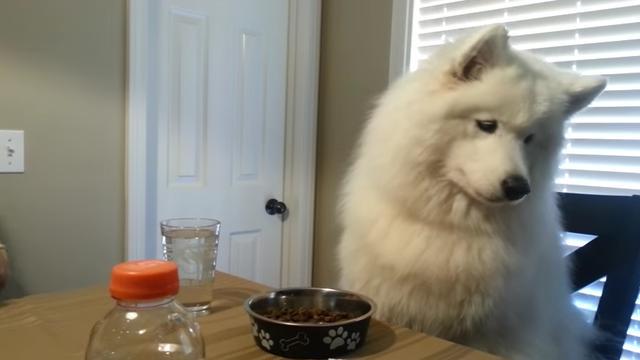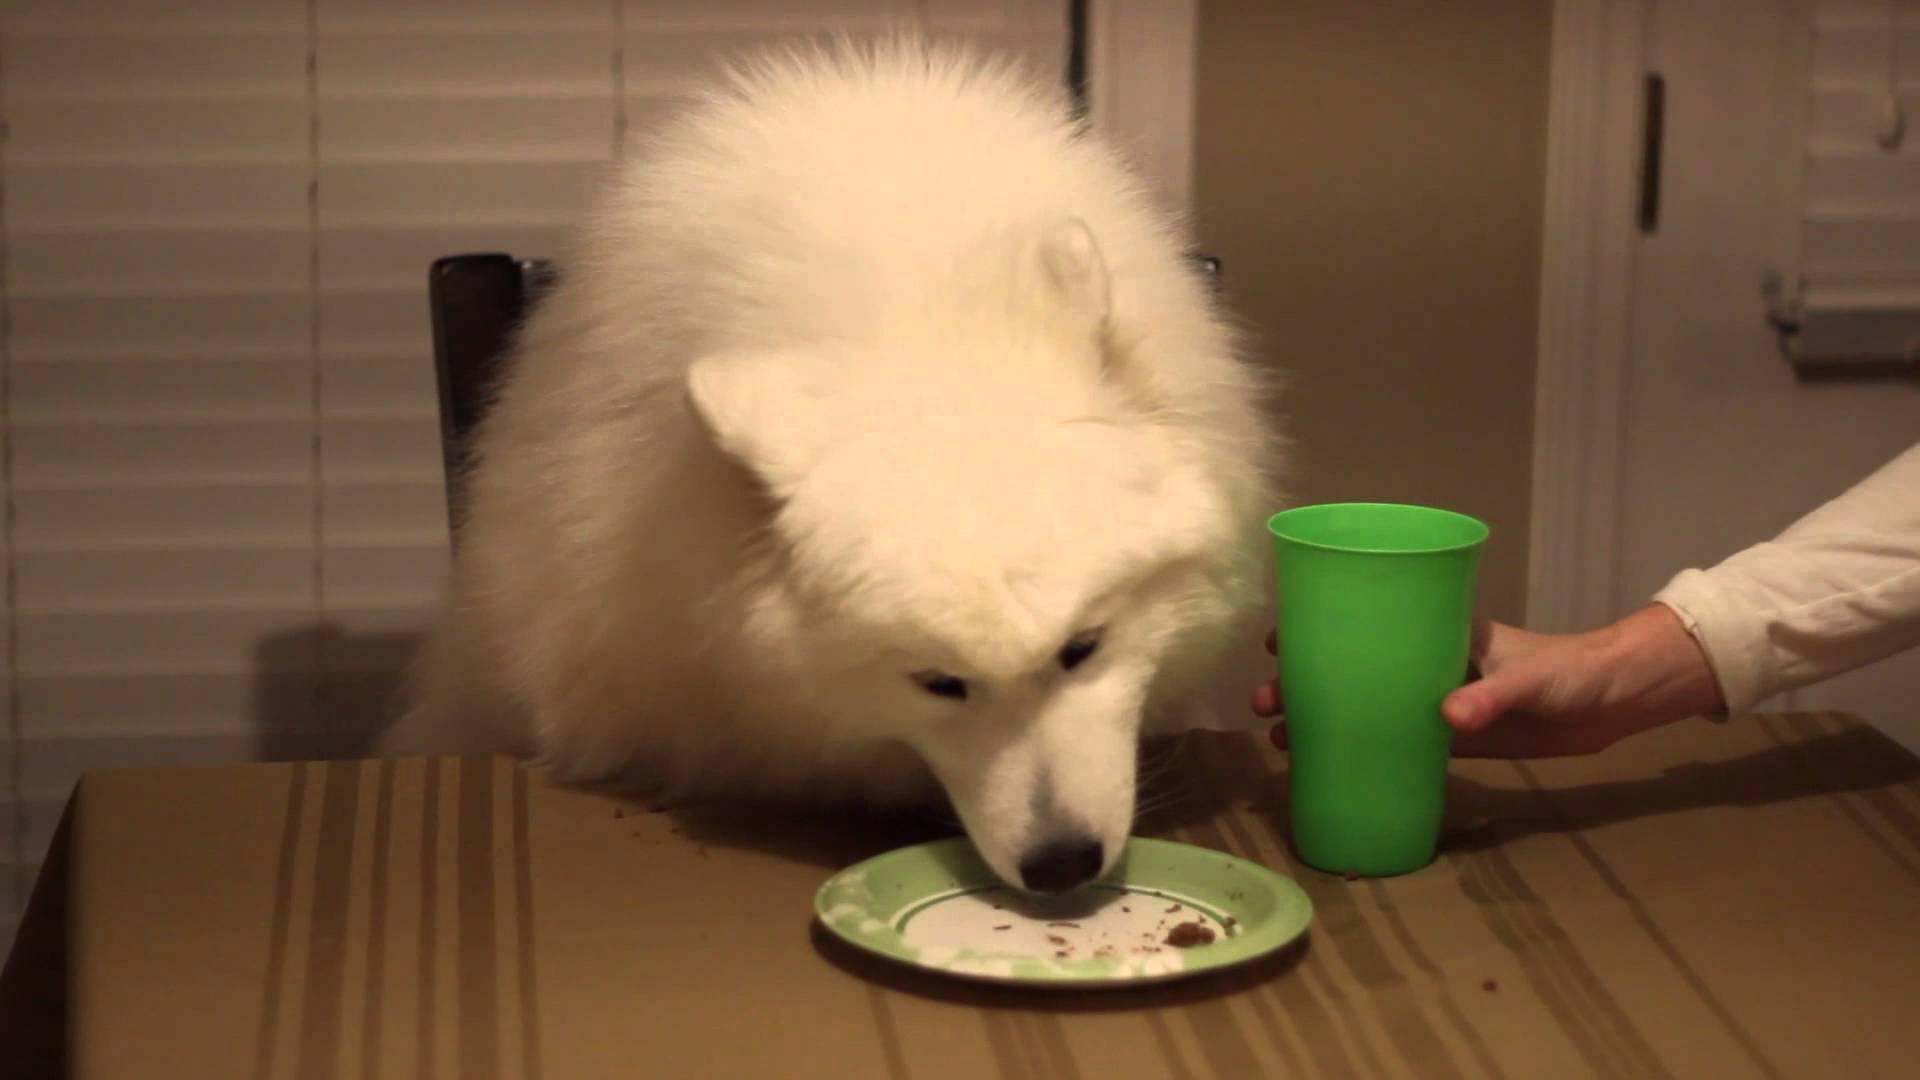The first image is the image on the left, the second image is the image on the right. Assess this claim about the two images: "An image shows a person's hand reaching from the right to offer something tasty to a white dog.". Correct or not? Answer yes or no. Yes. The first image is the image on the left, the second image is the image on the right. For the images shown, is this caption "A person is placing something on a table in front of a dog in only one of the images." true? Answer yes or no. Yes. 